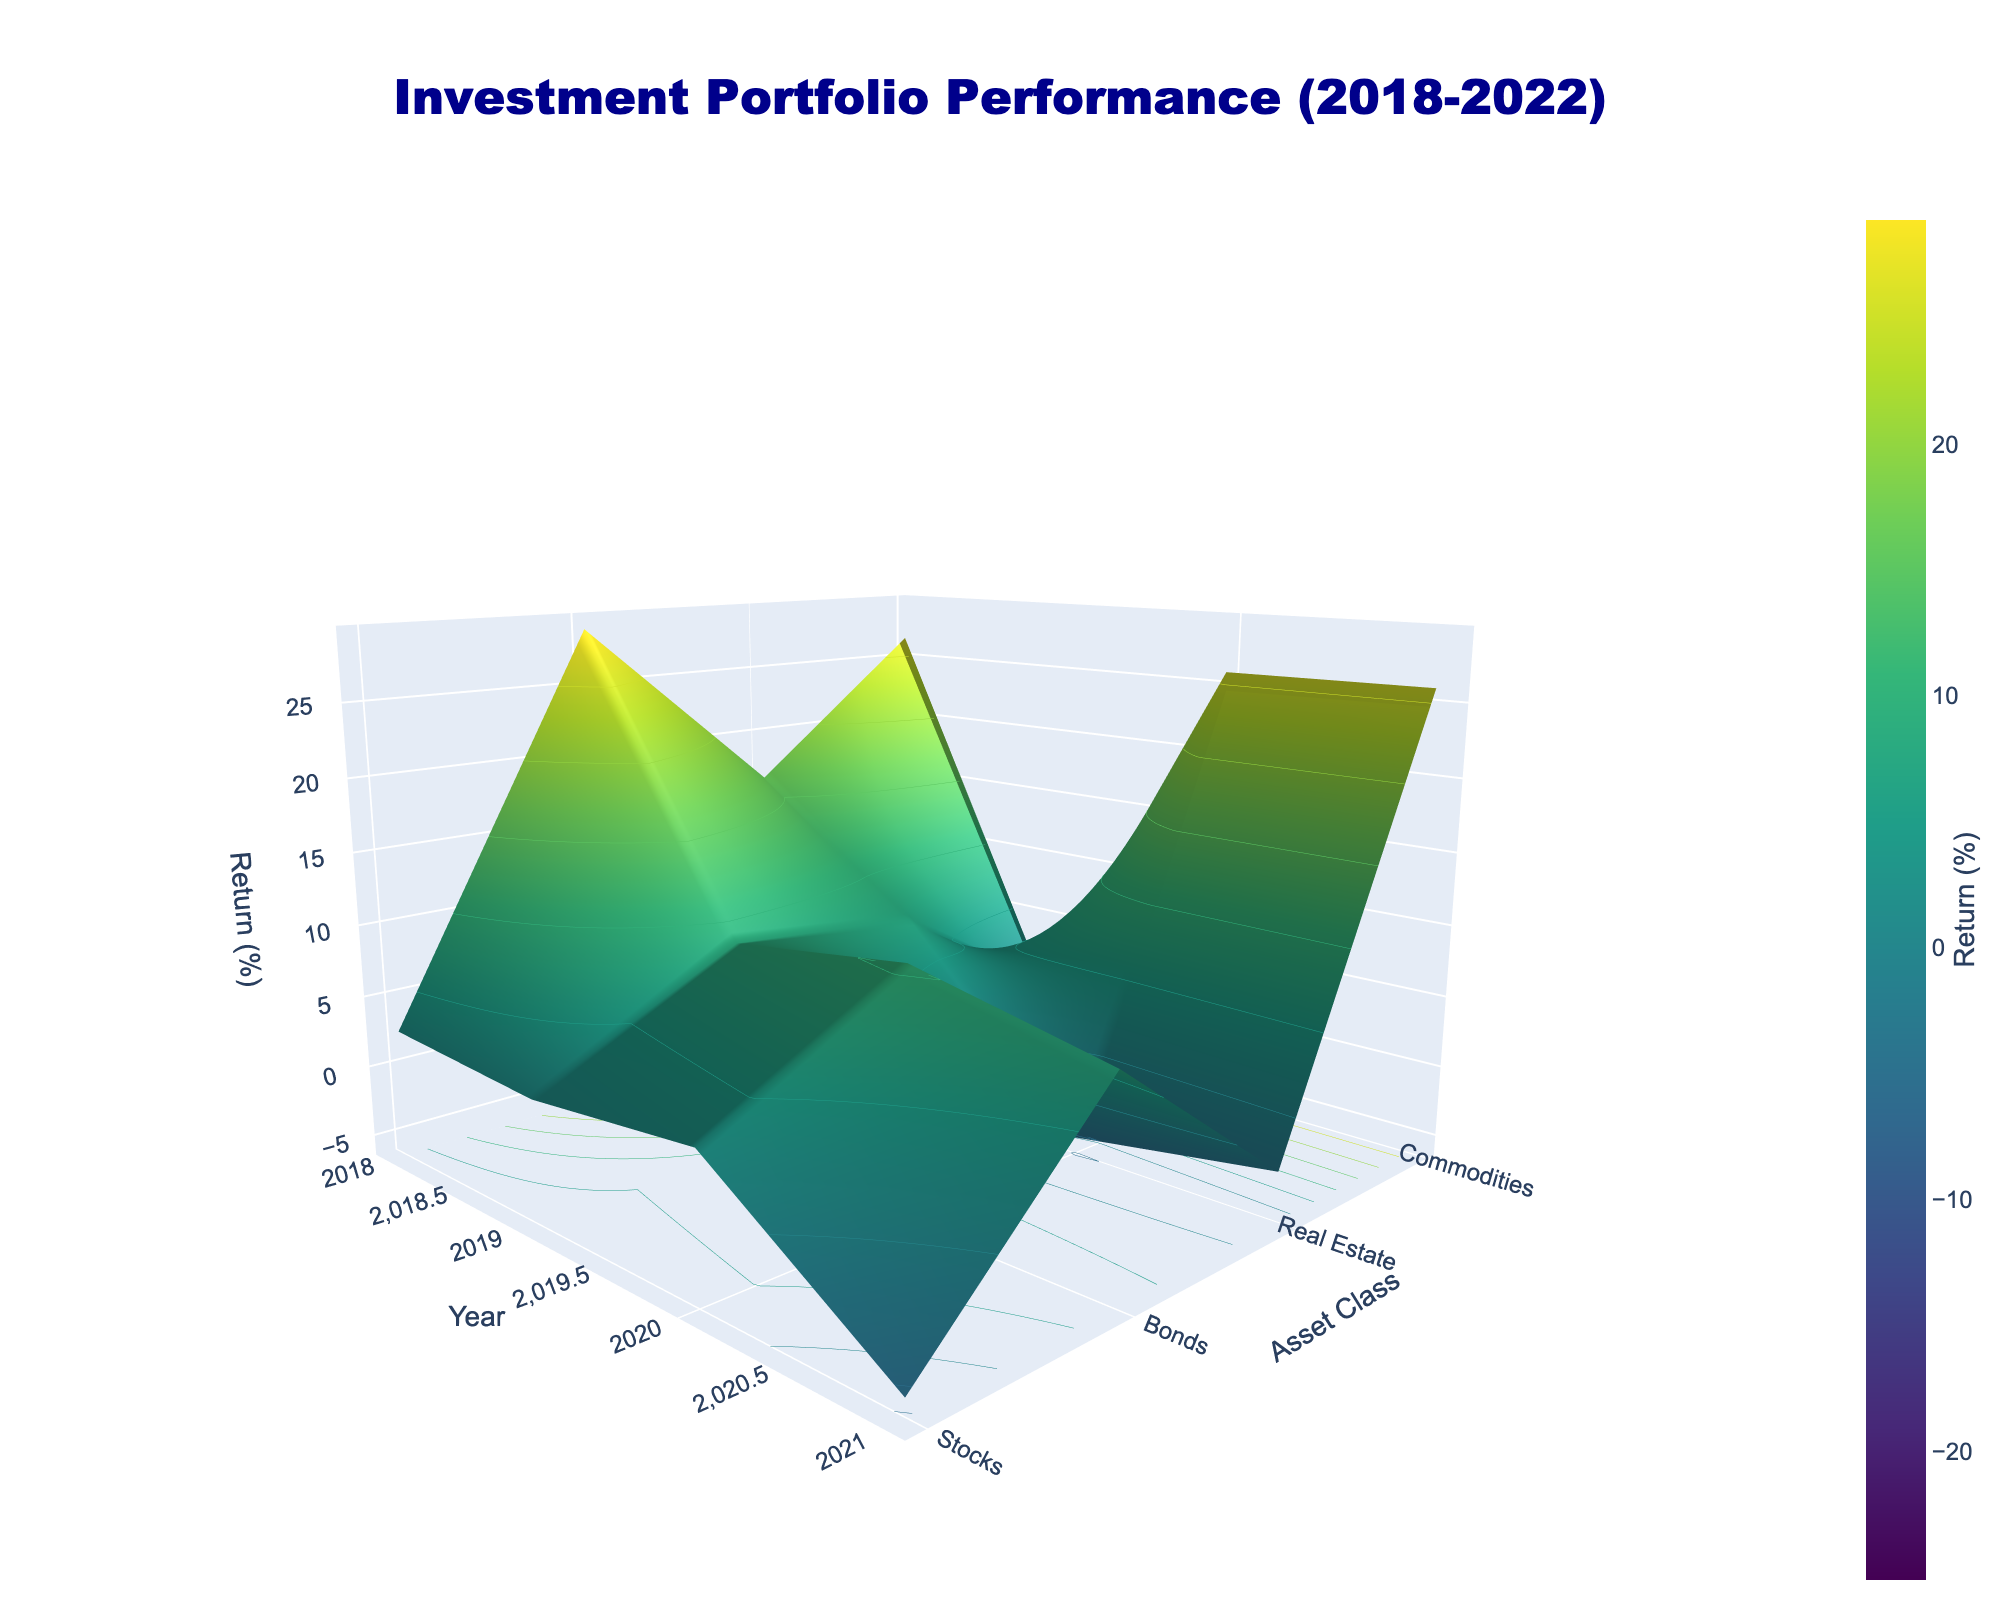What is the title of the 3D surface plot? The title of the plot is typically positioned at the top. Look for the main heading in a larger and bold-faced font.
Answer: Investment Portfolio Performance (2018-2022) What are the axis labels in the plot? The axis labels are usually positioned along the axes. For a 3D surface plot, search for them on the X, Y, and Z axes.
Answer: Year, Asset Class, Return (%) Which asset class had the highest return in 2021? Locate the year 2021 on the X-axis, trace upward to identify the highest point on the Z-axis, then follow to the Y-axis to find the corresponding asset class.
Answer: Real Estate and Commodities How did the returns of Stocks change from 2019 to 2020? Check the return values for Stocks in both 2019 and 2020.
Answer: Decreased from 28.9% in 2019 to 16.3% in 2020 Which year had the worst performance for Bonds? Look for the lowest point on the surface plot for Bonds throughout different years.
Answer: 2022 What is the average return of Real Estate from 2018 to 2022? Find the return values of Real Estate for each year, sum them up, and then divide by the number of years (5).
Answer: (3.2 + 10.5 - 5.3 + 27.1 - 25.1)/5 = 2.08% Compare the returns of Commodities and Stocks in 2022. Which one performed better? Locate the return values of Commodities and Stocks for 2022 and compare them.
Answer: Commodities performed better (16.1% vs -19.4%) For how many years did Bonds have positive returns? Check the return values for Bonds each year and count the years with positive returns.
Answer: 3 years (2018, 2019, 2020) In which year did Real Estate have the highest negative return? Look for the most negative point for Real Estate across all years.
Answer: 2022 What was the trend in the return of Stocks from 2018 to 2022? Examine the surface plot for Stocks to identify the overall movement across the years.
Answer: The return rose significantly in 2019, had a moderate dip in 2020, rose again in 2021, and finally dropped sharply in 2022 